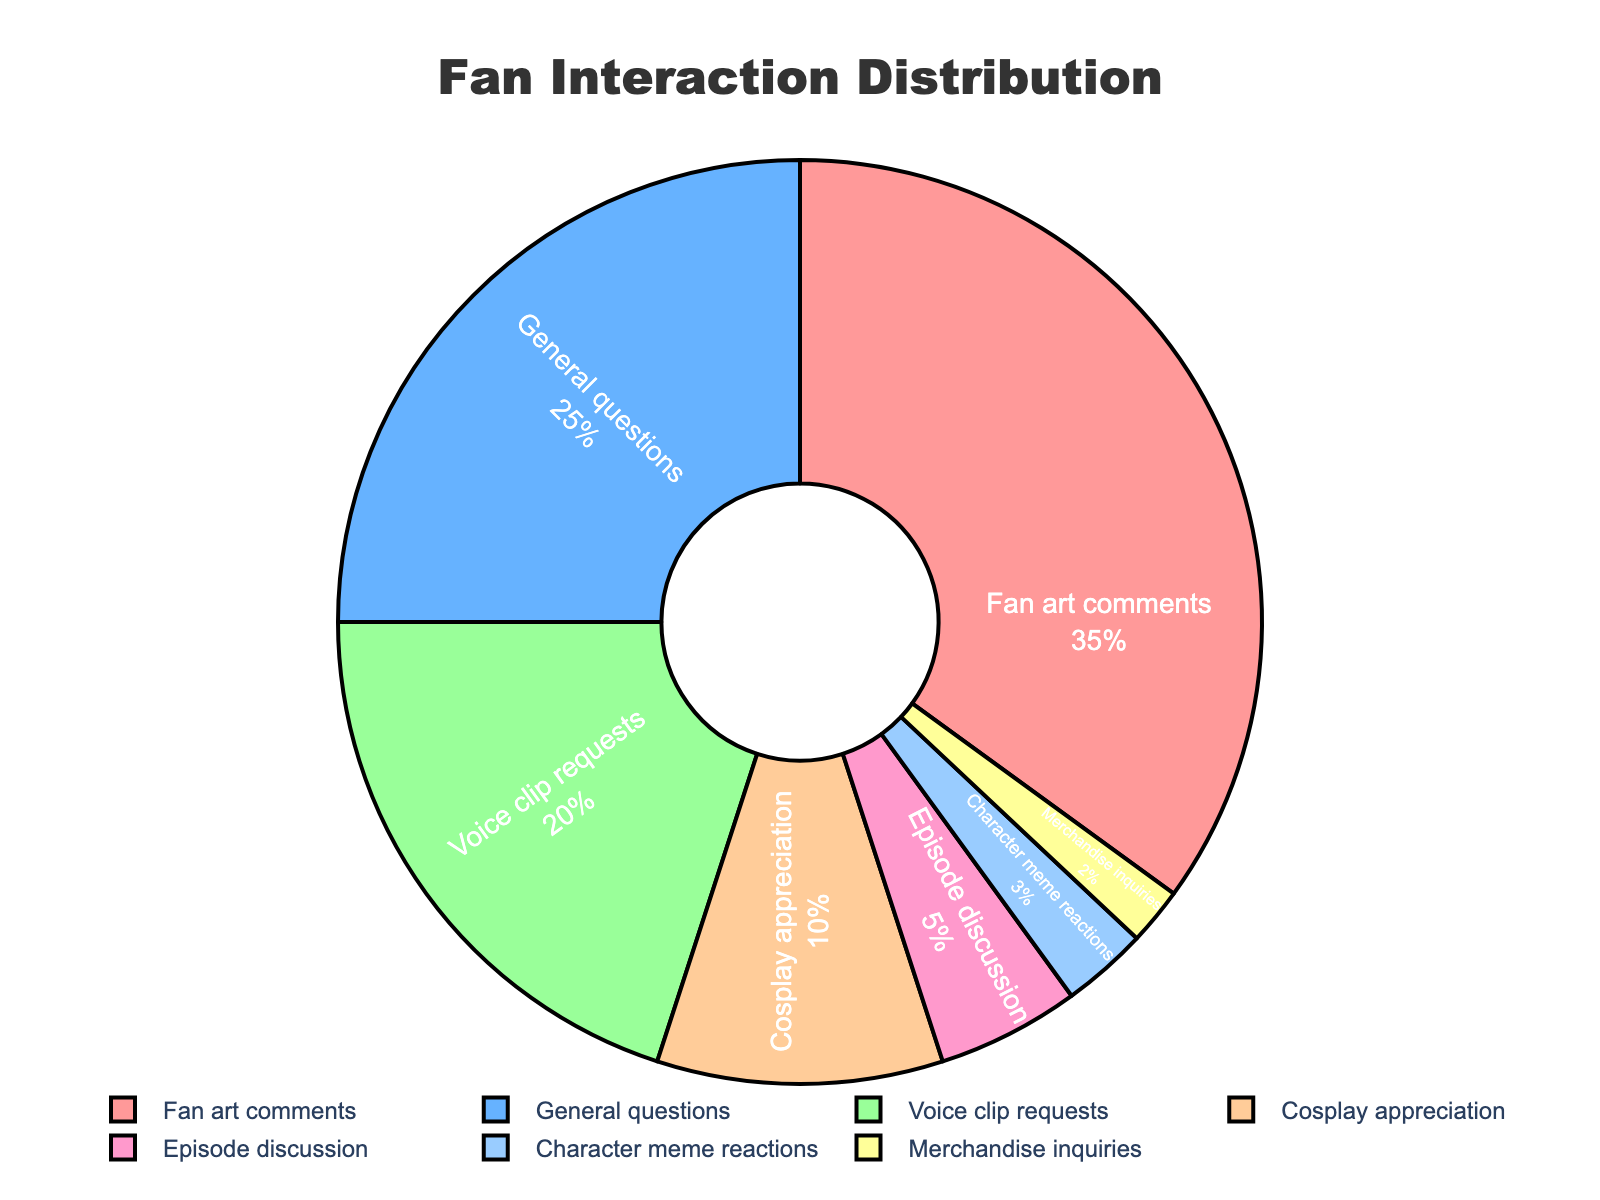Which content type has the highest percentage of fan interactions? From the pie chart, "Fan art comments" take up the largest portion, indicating the highest percentage of fan interactions.
Answer: Fan art comments What is the combined percentage of "General questions" and "Voice clip requests"? The percentage for "General questions" is 25% and for "Voice clip requests" is 20%. Adding these two percentages gives 25% + 20% = 45%.
Answer: 45% How much greater is the percentage of "Fan art comments" compared to "Episode discussion"? "Fan art comments" have a percentage of 35% and "Episode discussion" has 5%. Subtracting the smaller percentage from the larger one gives 35% - 5% = 30%.
Answer: 30% Which content types together make up less than 10% of fan interactions? "Character meme reactions" account for 3%, and "Merchandise inquiries" account for 2%. Together, these add up to 3% + 2% = 5%, which is less than 10%.
Answer: Character meme reactions and Merchandise inquiries Among the content types that make up more than 20% of fan interactions, which has the highest percentage? The pie chart shows that "Fan art comments" has 35% and "General questions" has 25%. Although both are above 20%, "Fan art comments" has a higher percentage.
Answer: Fan art comments What is the difference in percentage between "Cosplay appreciation" and "Voice clip requests"? "Cosplay appreciation" has a percentage of 10%, and "Voice clip requests" have 20%. The difference is 20% - 10% = 10%.
Answer: 10% Which content type has the smallest percentage of fan interactions? The smallest segment in the pie chart belongs to "Merchandise inquiries," which accounts for 2%.
Answer: Merchandise inquiries If "Character meme reactions" increased by 1%, would it surpass "Episode discussion"? "Character meme reactions" currently stand at 3%, and "Episode discussion" is at 5%. If "Character meme reactions" increased by 1%, it would be 3% + 1% = 4%, which is still less than 5%.
Answer: No What is the total percentage of fan interactions for "Cosplay appreciation" and "Episode discussion"? "Cosplay appreciation" accounts for 10%, and "Episode discussion" accounts for 5%. Adding these two percentages gives 10% + 5% = 15%.
Answer: 15% Is the percentage of "General questions" more than twice the percentage of "Cosplay appreciation"? "General questions" account for 25%, and "Cosplay appreciation" accounts for 10%. Twice of "Cosplay appreciation" is 10% * 2 = 20%, which is less than 25%, so the percentage of "General questions" is more than twice "Cosplay appreciation."
Answer: Yes 